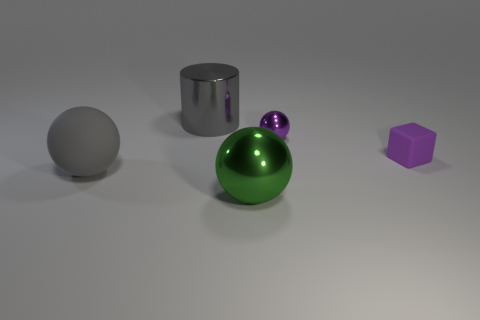Can you describe the lighting in the scene? The scene is lit from above, as indicated by the soft shadows under the objects. The light source appears to be diffused, creating a soft illumination without harsh highlights. 